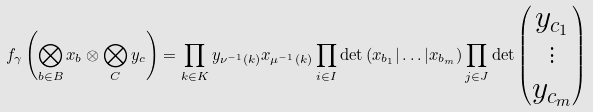<formula> <loc_0><loc_0><loc_500><loc_500>f _ { \gamma } \left ( \bigotimes _ { b \in B } x _ { b } \otimes \bigotimes _ { C } y _ { c } \right ) = \prod _ { k \in K } y _ { \nu ^ { - 1 } ( k ) } x _ { \mu ^ { - 1 } ( k ) } \prod _ { i \in I } \det \left ( x _ { b _ { 1 } } | \dots | x _ { b _ { m } } \right ) \prod _ { j \in J } \det \begin{pmatrix} y _ { c _ { 1 } } \\ \vdots \\ y _ { c _ { m } } \end{pmatrix}</formula> 